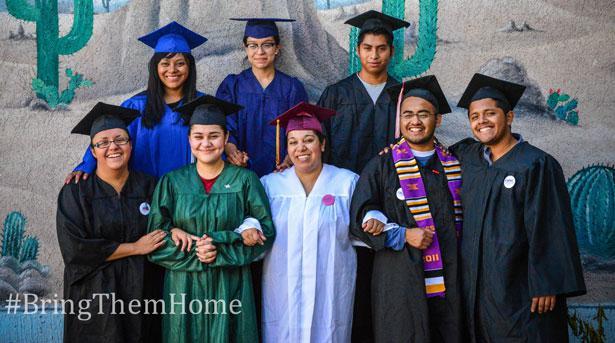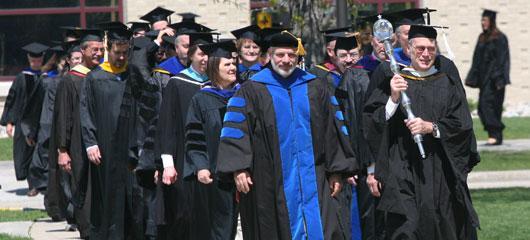The first image is the image on the left, the second image is the image on the right. Examine the images to the left and right. Is the description "One image has exactly four people in the foreground." accurate? Answer yes or no. No. The first image is the image on the left, the second image is the image on the right. Analyze the images presented: Is the assertion "There is a single black male wearing a cap and gowns with a set of tassels hanging down around his neck." valid? Answer yes or no. No. 